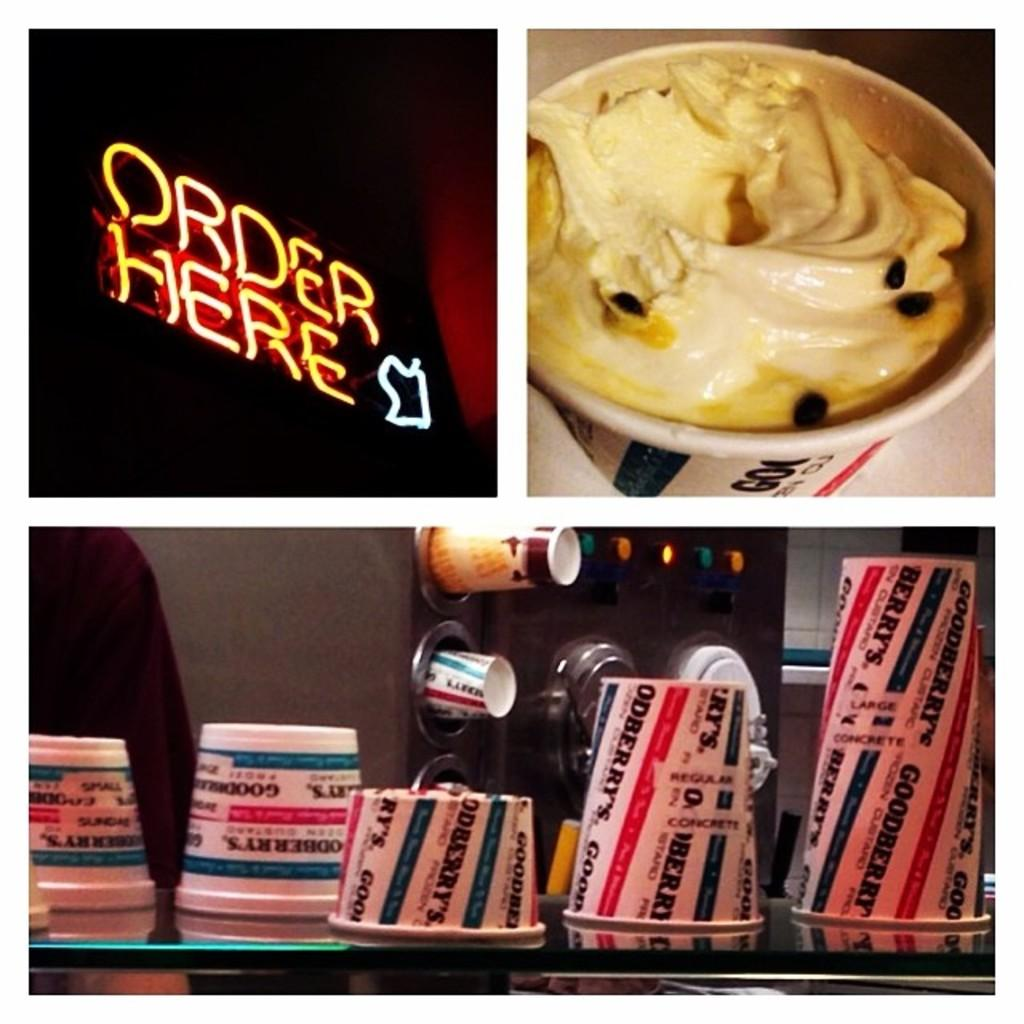<image>
Write a terse but informative summary of the picture. Cups, a bowl of food and an Order Here sign. 